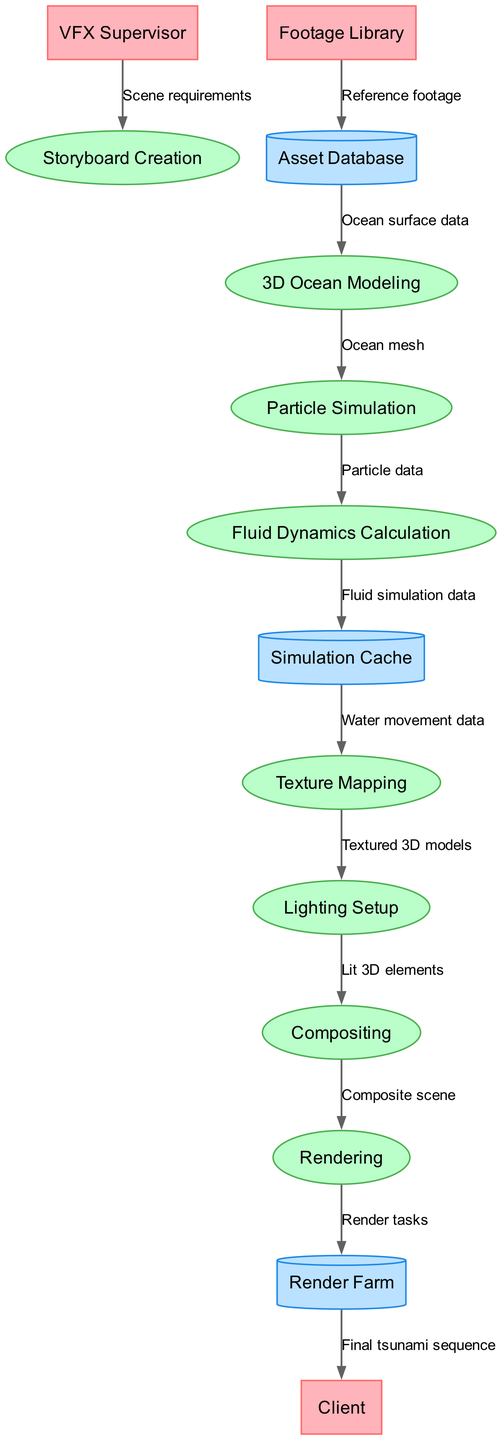What is the first process in the visual effects pipeline? The first process listed in the diagram is "Storyboard Creation." This can be identified as it appears at the top of the processes section in the flowchart.
Answer: Storyboard Creation How many external entities are present in the diagram? Counting the external entities listed—VFX Supervisor, Client, and Footage Library—we find a total of three external entities depicted in the diagram.
Answer: 3 Which data store receives fluid simulation data? The "Simulation Cache" data store receives "Fluid simulation data," which is indicated by the directed flow from "Fluid Dynamics Calculation" to "Simulation Cache" in the diagram.
Answer: Simulation Cache What data flows from the Particle Simulation to Fluid Dynamics Calculation? The data that flows from "Particle Simulation" to "Fluid Dynamics Calculation" is "Particle data," as stated on the directed edge connecting these two nodes in the diagram.
Answer: Particle data What is the final output of the pipeline that is delivered to the client? The final output of the pipeline delivered to the client is the "Final tsunami sequence," which is indicated by the flow from "Render Farm" to "Client."
Answer: Final tsunami sequence What process directly follows the Texture Mapping in the pipeline? The process that directly follows "Texture Mapping" in the diagram is "Lighting Setup," as shown by the flow from Texture Mapping to Lighting Setup.
Answer: Lighting Setup Which external entity contributes reference footage to the Asset Database? The external entity that contributes "Reference footage" to the "Asset Database" is the "Footage Library," as indicated in the data flow diagram.
Answer: Footage Library How many processes are involved in the visual effects pipeline? There are eight processes listed in the pipeline: Storyboard Creation, 3D Ocean Modeling, Particle Simulation, Fluid Dynamics Calculation, Texture Mapping, Lighting Setup, Compositing, and Rendering, which total to eight.
Answer: 8 